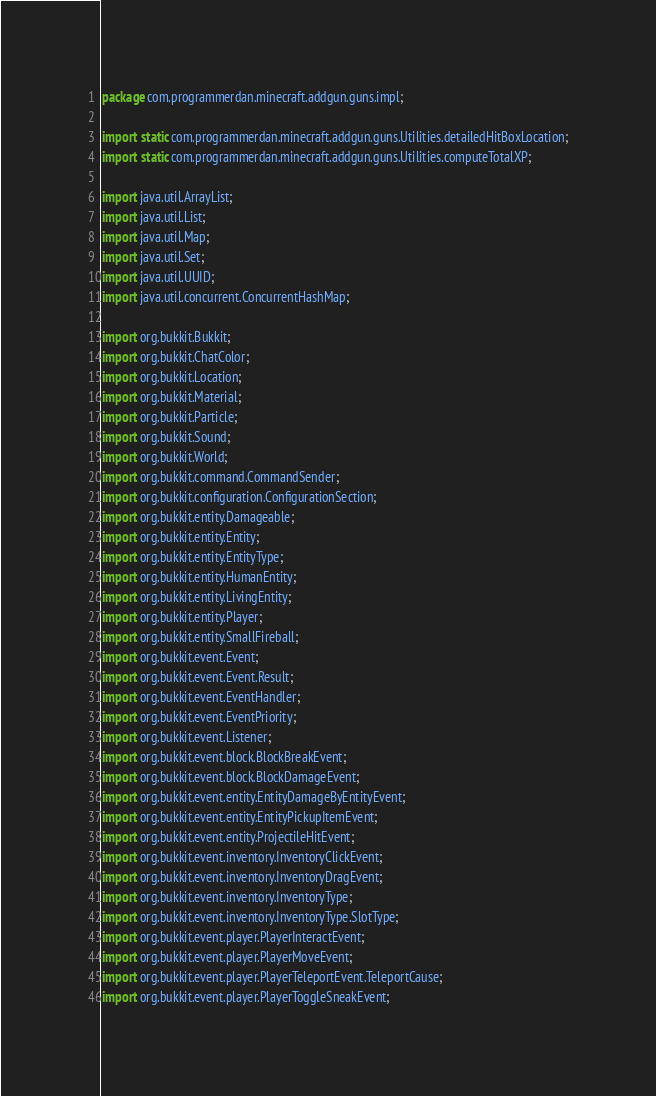Convert code to text. <code><loc_0><loc_0><loc_500><loc_500><_Java_>package com.programmerdan.minecraft.addgun.guns.impl;

import static com.programmerdan.minecraft.addgun.guns.Utilities.detailedHitBoxLocation;
import static com.programmerdan.minecraft.addgun.guns.Utilities.computeTotalXP;

import java.util.ArrayList;
import java.util.List;
import java.util.Map;
import java.util.Set;
import java.util.UUID;
import java.util.concurrent.ConcurrentHashMap;

import org.bukkit.Bukkit;
import org.bukkit.ChatColor;
import org.bukkit.Location;
import org.bukkit.Material;
import org.bukkit.Particle;
import org.bukkit.Sound;
import org.bukkit.World;
import org.bukkit.command.CommandSender;
import org.bukkit.configuration.ConfigurationSection;
import org.bukkit.entity.Damageable;
import org.bukkit.entity.Entity;
import org.bukkit.entity.EntityType;
import org.bukkit.entity.HumanEntity;
import org.bukkit.entity.LivingEntity;
import org.bukkit.entity.Player;
import org.bukkit.entity.SmallFireball;
import org.bukkit.event.Event;
import org.bukkit.event.Event.Result;
import org.bukkit.event.EventHandler;
import org.bukkit.event.EventPriority;
import org.bukkit.event.Listener;
import org.bukkit.event.block.BlockBreakEvent;
import org.bukkit.event.block.BlockDamageEvent;
import org.bukkit.event.entity.EntityDamageByEntityEvent;
import org.bukkit.event.entity.EntityPickupItemEvent;
import org.bukkit.event.entity.ProjectileHitEvent;
import org.bukkit.event.inventory.InventoryClickEvent;
import org.bukkit.event.inventory.InventoryDragEvent;
import org.bukkit.event.inventory.InventoryType;
import org.bukkit.event.inventory.InventoryType.SlotType;
import org.bukkit.event.player.PlayerInteractEvent;
import org.bukkit.event.player.PlayerMoveEvent;
import org.bukkit.event.player.PlayerTeleportEvent.TeleportCause;
import org.bukkit.event.player.PlayerToggleSneakEvent;</code> 